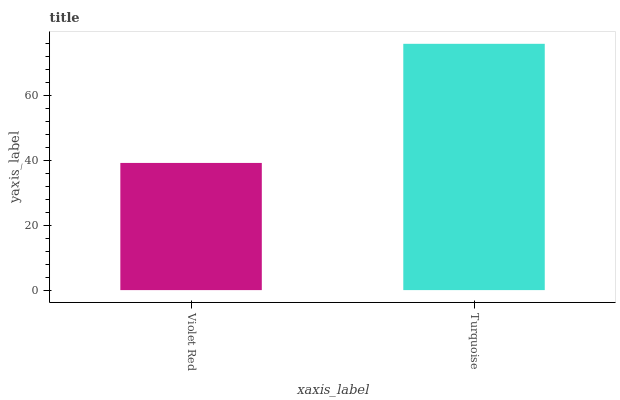Is Violet Red the minimum?
Answer yes or no. Yes. Is Turquoise the maximum?
Answer yes or no. Yes. Is Turquoise the minimum?
Answer yes or no. No. Is Turquoise greater than Violet Red?
Answer yes or no. Yes. Is Violet Red less than Turquoise?
Answer yes or no. Yes. Is Violet Red greater than Turquoise?
Answer yes or no. No. Is Turquoise less than Violet Red?
Answer yes or no. No. Is Turquoise the high median?
Answer yes or no. Yes. Is Violet Red the low median?
Answer yes or no. Yes. Is Violet Red the high median?
Answer yes or no. No. Is Turquoise the low median?
Answer yes or no. No. 